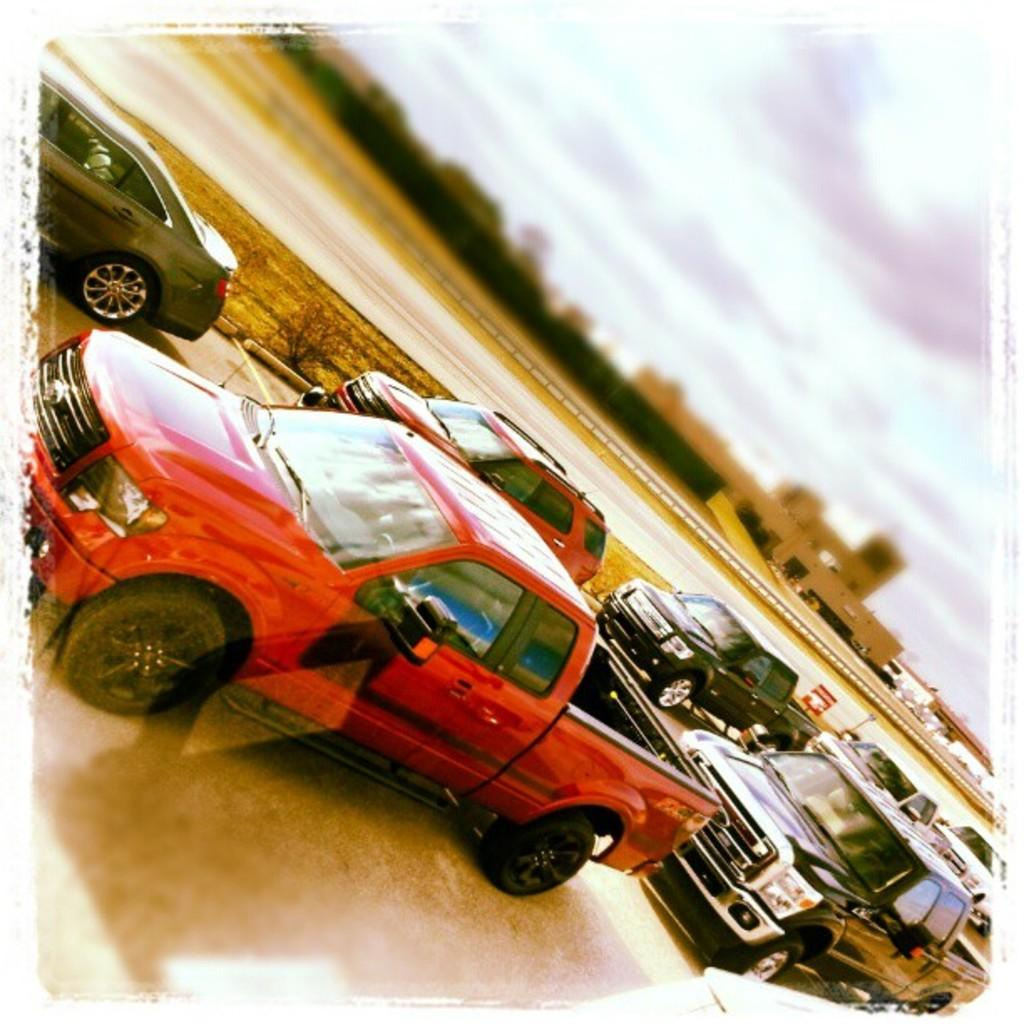What can be seen in the sky in the image? The sky is visible in the image. What type of structures are present in the image? There are buildings in the image. What other elements can be found in the image besides buildings? There are plants, a road, vehicles, and a board in the image. What statement does the home in the image make about the country's architecture? There is no home present in the image, only buildings and other elements. Therefore, it is not possible to make a statement about the country's architecture based on the image. 